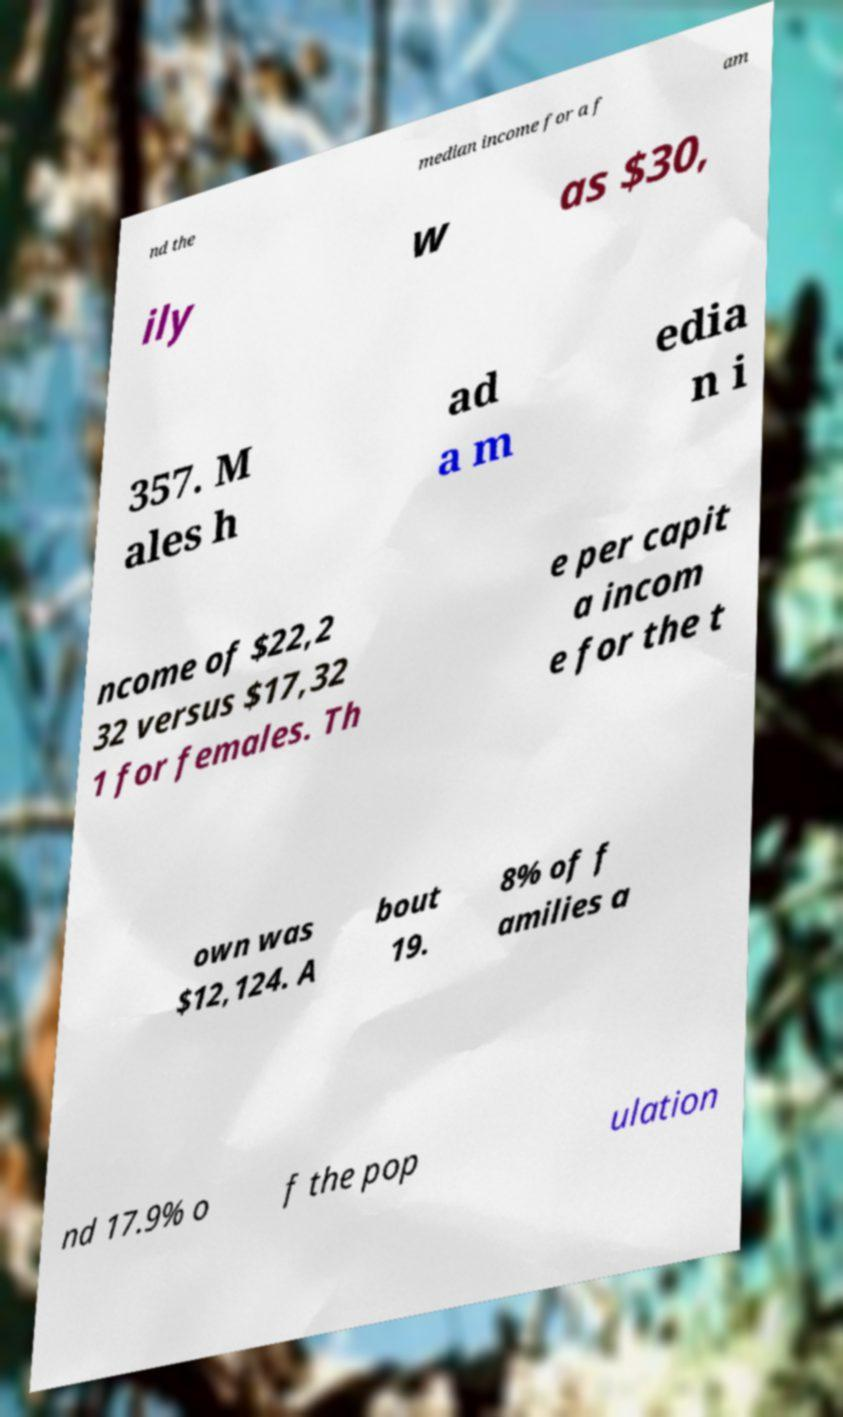Can you read and provide the text displayed in the image?This photo seems to have some interesting text. Can you extract and type it out for me? nd the median income for a f am ily w as $30, 357. M ales h ad a m edia n i ncome of $22,2 32 versus $17,32 1 for females. Th e per capit a incom e for the t own was $12,124. A bout 19. 8% of f amilies a nd 17.9% o f the pop ulation 